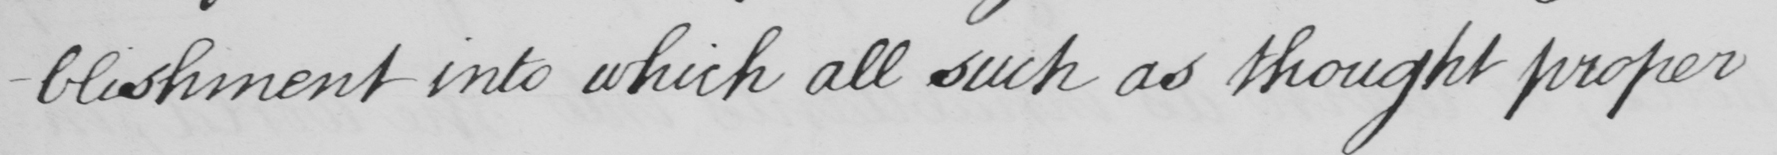Transcribe the text shown in this historical manuscript line. -blishment into which all such as thought proper 